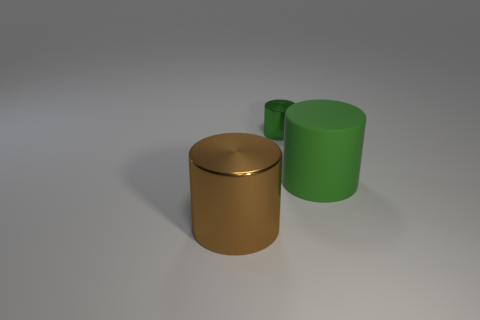Add 1 large brown cylinders. How many objects exist? 4 Subtract all purple blocks. Subtract all big brown shiny cylinders. How many objects are left? 2 Add 3 metal things. How many metal things are left? 5 Add 1 tiny metallic objects. How many tiny metallic objects exist? 2 Subtract 0 purple balls. How many objects are left? 3 